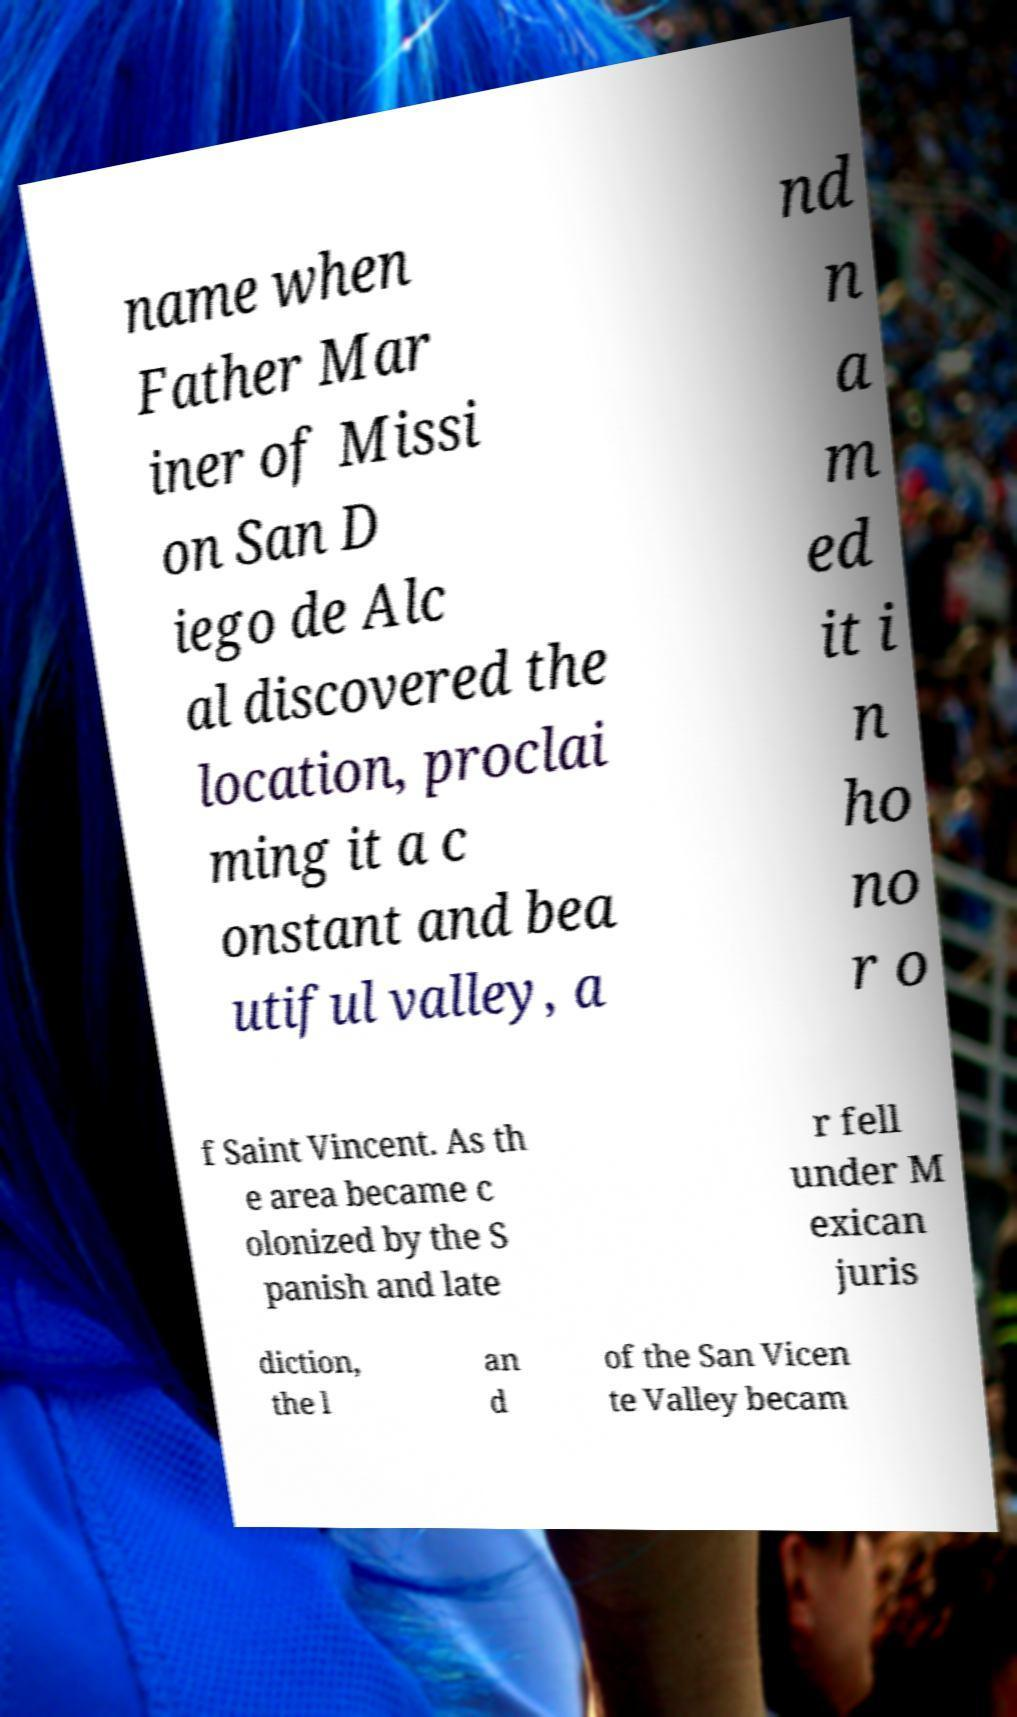Could you assist in decoding the text presented in this image and type it out clearly? name when Father Mar iner of Missi on San D iego de Alc al discovered the location, proclai ming it a c onstant and bea utiful valley, a nd n a m ed it i n ho no r o f Saint Vincent. As th e area became c olonized by the S panish and late r fell under M exican juris diction, the l an d of the San Vicen te Valley becam 